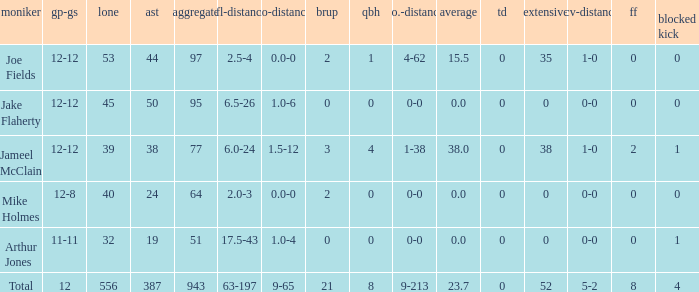Parse the full table. {'header': ['moniker', 'gp-gs', 'lone', 'ast', 'aggregate', 'tfl-distance', 'no-distance', 'brup', 'qbh', 'no.-distance', 'average', 'td', 'extensive', 'rcv-distance', 'ff', 'blocked kick'], 'rows': [['Joe Fields', '12-12', '53', '44', '97', '2.5-4', '0.0-0', '2', '1', '4-62', '15.5', '0', '35', '1-0', '0', '0'], ['Jake Flaherty', '12-12', '45', '50', '95', '6.5-26', '1.0-6', '0', '0', '0-0', '0.0', '0', '0', '0-0', '0', '0'], ['Jameel McClain', '12-12', '39', '38', '77', '6.0-24', '1.5-12', '3', '4', '1-38', '38.0', '0', '38', '1-0', '2', '1'], ['Mike Holmes', '12-8', '40', '24', '64', '2.0-3', '0.0-0', '2', '0', '0-0', '0.0', '0', '0', '0-0', '0', '0'], ['Arthur Jones', '11-11', '32', '19', '51', '17.5-43', '1.0-4', '0', '0', '0-0', '0.0', '0', '0', '0-0', '0', '1'], ['Total', '12', '556', '387', '943', '63-197', '9-65', '21', '8', '9-213', '23.7', '0', '52', '5-2', '8', '4']]} What is the largest number of tds scored for a player? 0.0. 